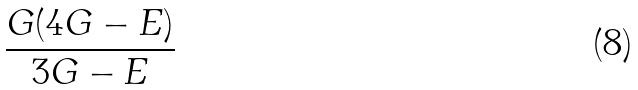Convert formula to latex. <formula><loc_0><loc_0><loc_500><loc_500>\frac { G ( 4 G - E ) } { 3 G - E }</formula> 